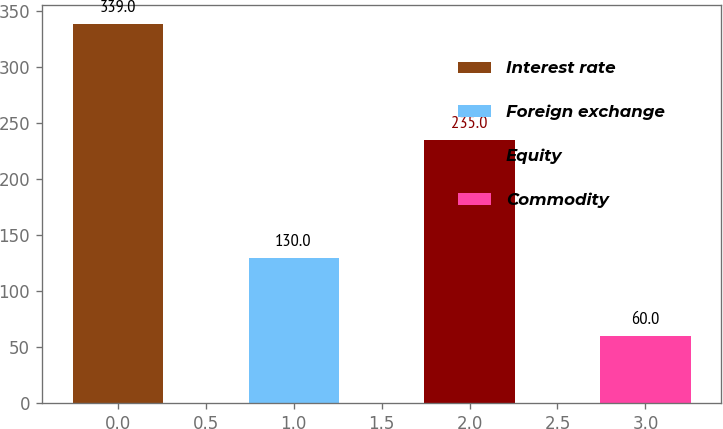Convert chart. <chart><loc_0><loc_0><loc_500><loc_500><bar_chart><fcel>Interest rate<fcel>Foreign exchange<fcel>Equity<fcel>Commodity<nl><fcel>339<fcel>130<fcel>235<fcel>60<nl></chart> 